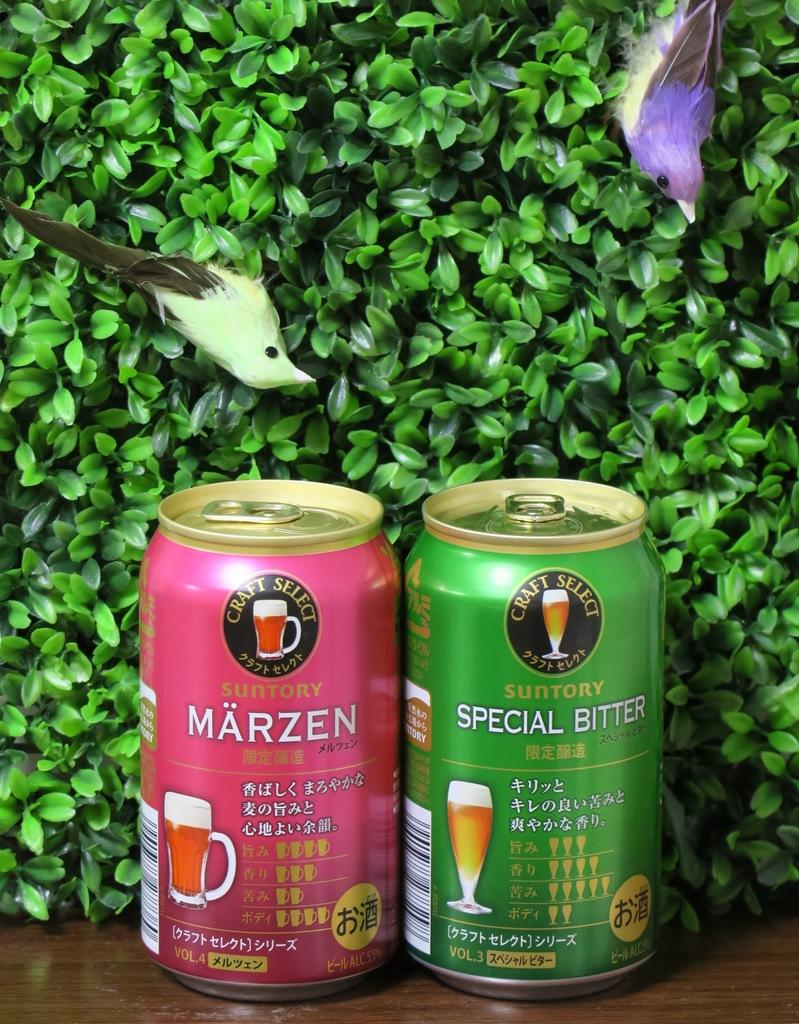<image>
Create a compact narrative representing the image presented. A can of Marzen sits next to a can of special bitter. 